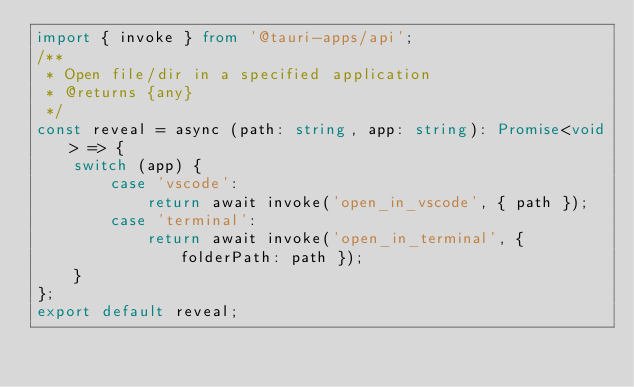Convert code to text. <code><loc_0><loc_0><loc_500><loc_500><_TypeScript_>import { invoke } from '@tauri-apps/api';
/**
 * Open file/dir in a specified application
 * @returns {any}
 */
const reveal = async (path: string, app: string): Promise<void> => {
	switch (app) {
		case 'vscode':
			return await invoke('open_in_vscode', { path });
		case 'terminal':
			return await invoke('open_in_terminal', { folderPath: path });
	}
};
export default reveal;
</code> 